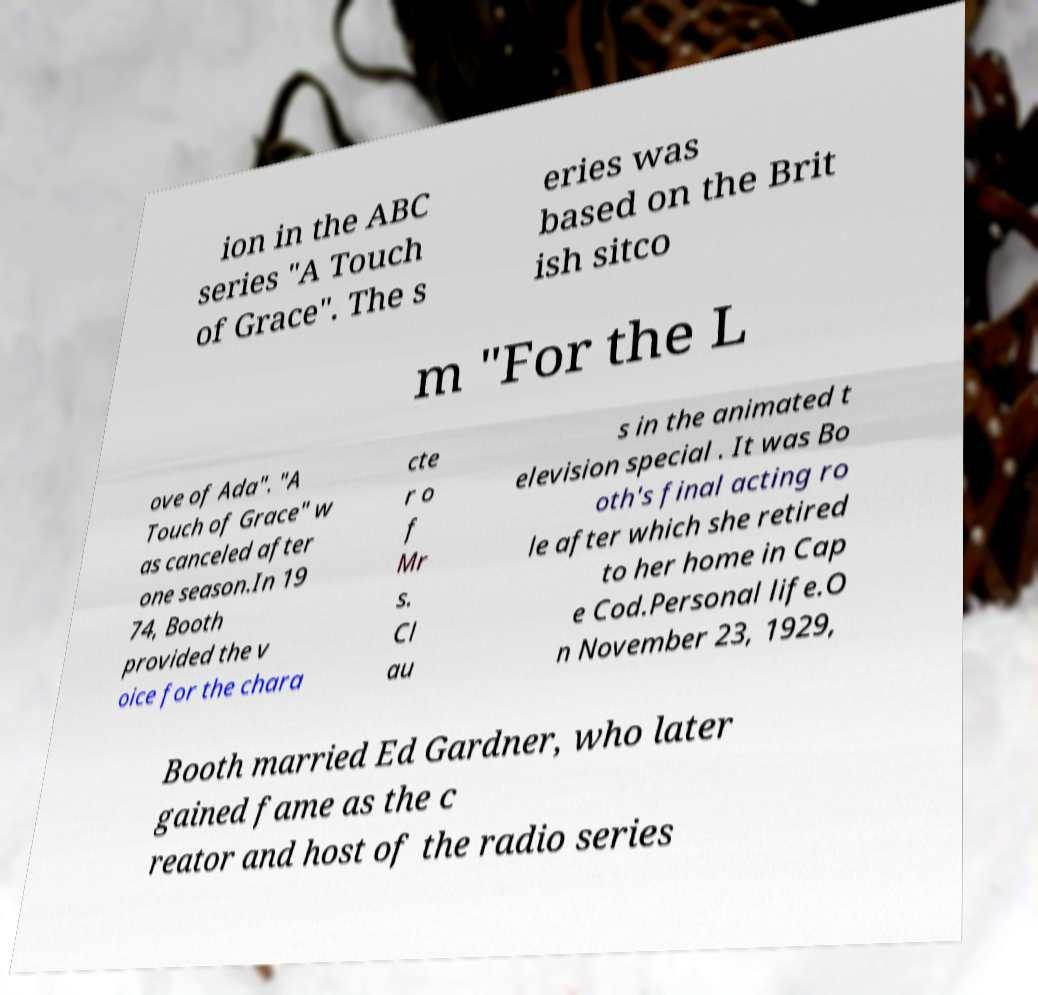There's text embedded in this image that I need extracted. Can you transcribe it verbatim? ion in the ABC series "A Touch of Grace". The s eries was based on the Brit ish sitco m "For the L ove of Ada". "A Touch of Grace" w as canceled after one season.In 19 74, Booth provided the v oice for the chara cte r o f Mr s. Cl au s in the animated t elevision special . It was Bo oth's final acting ro le after which she retired to her home in Cap e Cod.Personal life.O n November 23, 1929, Booth married Ed Gardner, who later gained fame as the c reator and host of the radio series 